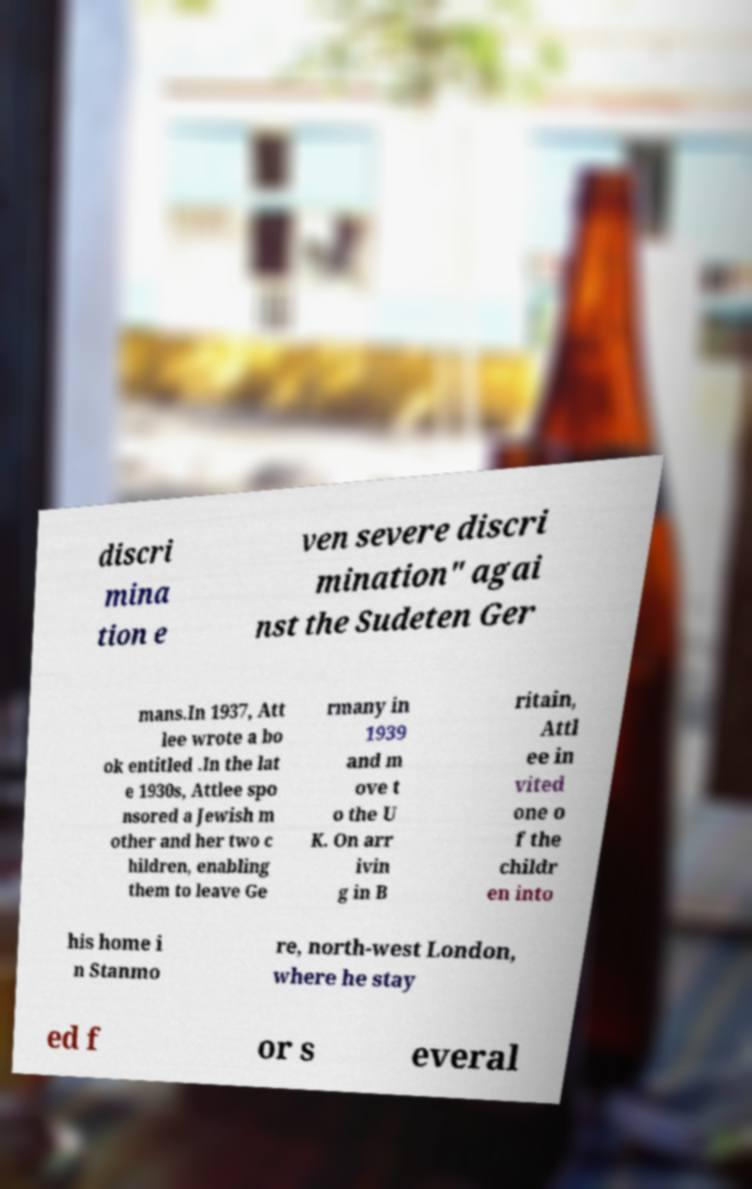There's text embedded in this image that I need extracted. Can you transcribe it verbatim? discri mina tion e ven severe discri mination" agai nst the Sudeten Ger mans.In 1937, Att lee wrote a bo ok entitled .In the lat e 1930s, Attlee spo nsored a Jewish m other and her two c hildren, enabling them to leave Ge rmany in 1939 and m ove t o the U K. On arr ivin g in B ritain, Attl ee in vited one o f the childr en into his home i n Stanmo re, north-west London, where he stay ed f or s everal 